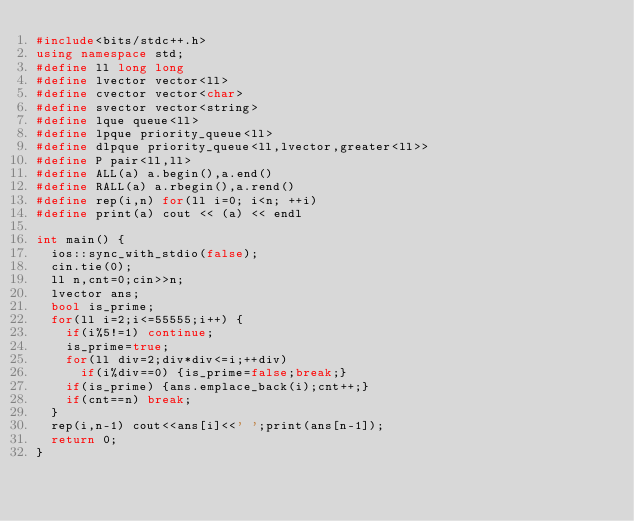Convert code to text. <code><loc_0><loc_0><loc_500><loc_500><_C++_>#include<bits/stdc++.h>
using namespace std;
#define ll long long
#define lvector vector<ll>
#define cvector vector<char>
#define svector vector<string>
#define lque queue<ll>
#define lpque priority_queue<ll>
#define dlpque priority_queue<ll,lvector,greater<ll>>
#define P pair<ll,ll>
#define ALL(a) a.begin(),a.end()
#define RALL(a) a.rbegin(),a.rend()
#define rep(i,n) for(ll i=0; i<n; ++i)
#define print(a) cout << (a) << endl

int main() {
  ios::sync_with_stdio(false);
  cin.tie(0);
  ll n,cnt=0;cin>>n;
  lvector ans;
  bool is_prime;
  for(ll i=2;i<=55555;i++) {
    if(i%5!=1) continue;
    is_prime=true;
    for(ll div=2;div*div<=i;++div) 
      if(i%div==0) {is_prime=false;break;}
    if(is_prime) {ans.emplace_back(i);cnt++;}
    if(cnt==n) break;
  }
  rep(i,n-1) cout<<ans[i]<<' ';print(ans[n-1]);
  return 0;
}</code> 